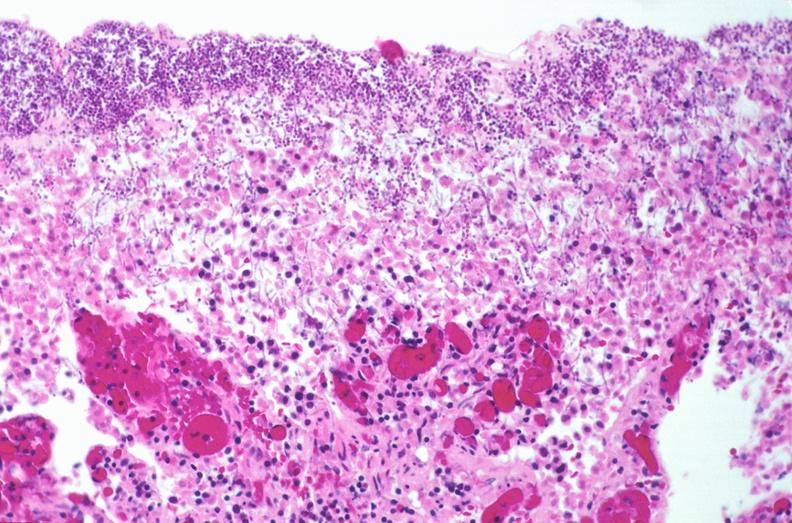where is this from?
Answer the question using a single word or phrase. Gastrointestinal system 